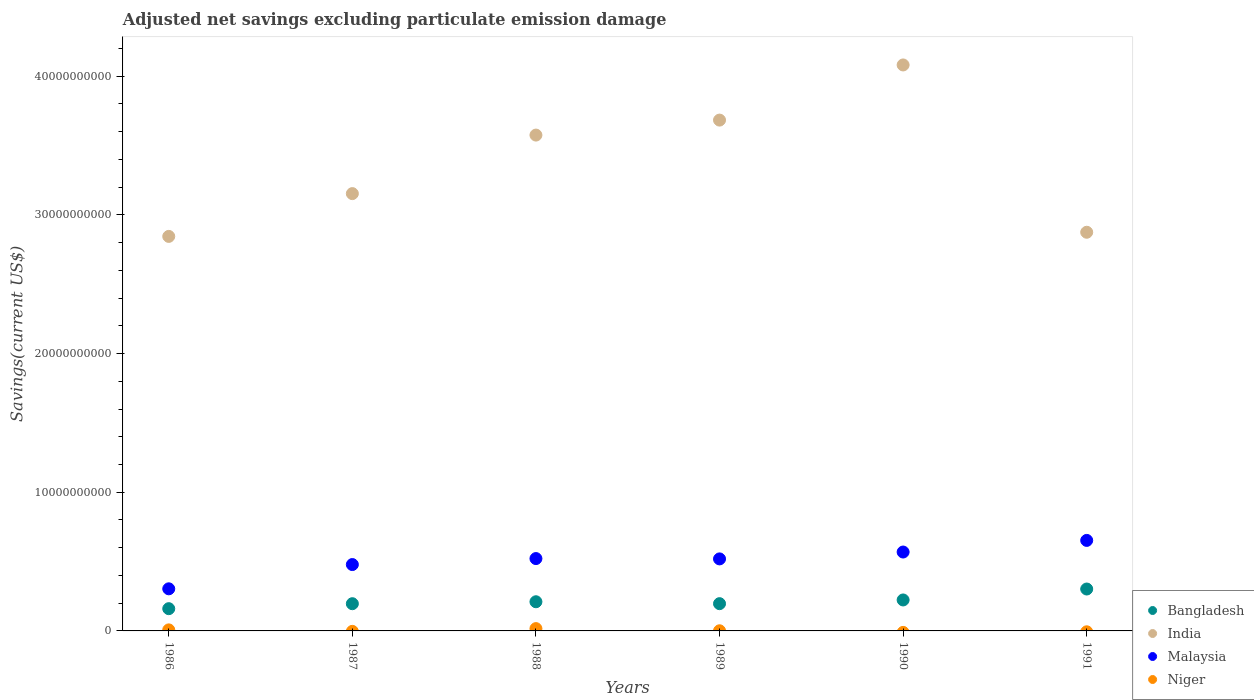What is the adjusted net savings in Malaysia in 1991?
Make the answer very short. 6.53e+09. Across all years, what is the maximum adjusted net savings in Niger?
Provide a succinct answer. 1.66e+08. Across all years, what is the minimum adjusted net savings in Bangladesh?
Ensure brevity in your answer.  1.60e+09. What is the total adjusted net savings in Niger in the graph?
Your response must be concise. 2.52e+08. What is the difference between the adjusted net savings in India in 1986 and that in 1991?
Offer a terse response. -2.99e+08. What is the difference between the adjusted net savings in Malaysia in 1986 and the adjusted net savings in Niger in 1987?
Your answer should be very brief. 3.04e+09. What is the average adjusted net savings in Bangladesh per year?
Offer a terse response. 2.15e+09. In the year 1989, what is the difference between the adjusted net savings in Malaysia and adjusted net savings in Niger?
Provide a short and direct response. 5.18e+09. In how many years, is the adjusted net savings in India greater than 30000000000 US$?
Make the answer very short. 4. What is the ratio of the adjusted net savings in Malaysia in 1986 to that in 1987?
Make the answer very short. 0.63. Is the adjusted net savings in Bangladesh in 1987 less than that in 1991?
Your answer should be compact. Yes. Is the difference between the adjusted net savings in Malaysia in 1986 and 1988 greater than the difference between the adjusted net savings in Niger in 1986 and 1988?
Make the answer very short. No. What is the difference between the highest and the second highest adjusted net savings in Malaysia?
Your response must be concise. 8.38e+08. What is the difference between the highest and the lowest adjusted net savings in Bangladesh?
Offer a terse response. 1.42e+09. Is the sum of the adjusted net savings in Niger in 1988 and 1989 greater than the maximum adjusted net savings in Malaysia across all years?
Give a very brief answer. No. Is it the case that in every year, the sum of the adjusted net savings in Bangladesh and adjusted net savings in Niger  is greater than the sum of adjusted net savings in India and adjusted net savings in Malaysia?
Offer a very short reply. Yes. Is it the case that in every year, the sum of the adjusted net savings in Bangladesh and adjusted net savings in India  is greater than the adjusted net savings in Malaysia?
Make the answer very short. Yes. Does the adjusted net savings in Malaysia monotonically increase over the years?
Offer a terse response. No. Is the adjusted net savings in Niger strictly greater than the adjusted net savings in Malaysia over the years?
Offer a terse response. No. How many dotlines are there?
Your response must be concise. 4. What is the difference between two consecutive major ticks on the Y-axis?
Keep it short and to the point. 1.00e+1. Where does the legend appear in the graph?
Ensure brevity in your answer.  Bottom right. How are the legend labels stacked?
Give a very brief answer. Vertical. What is the title of the graph?
Offer a terse response. Adjusted net savings excluding particulate emission damage. Does "Chile" appear as one of the legend labels in the graph?
Your answer should be compact. No. What is the label or title of the X-axis?
Your response must be concise. Years. What is the label or title of the Y-axis?
Give a very brief answer. Savings(current US$). What is the Savings(current US$) in Bangladesh in 1986?
Offer a very short reply. 1.60e+09. What is the Savings(current US$) of India in 1986?
Offer a terse response. 2.85e+1. What is the Savings(current US$) in Malaysia in 1986?
Provide a succinct answer. 3.04e+09. What is the Savings(current US$) of Niger in 1986?
Your answer should be very brief. 7.51e+07. What is the Savings(current US$) in Bangladesh in 1987?
Provide a short and direct response. 1.96e+09. What is the Savings(current US$) in India in 1987?
Offer a very short reply. 3.15e+1. What is the Savings(current US$) in Malaysia in 1987?
Keep it short and to the point. 4.79e+09. What is the Savings(current US$) of Bangladesh in 1988?
Your answer should be compact. 2.10e+09. What is the Savings(current US$) of India in 1988?
Offer a very short reply. 3.58e+1. What is the Savings(current US$) of Malaysia in 1988?
Your answer should be very brief. 5.22e+09. What is the Savings(current US$) in Niger in 1988?
Keep it short and to the point. 1.66e+08. What is the Savings(current US$) in Bangladesh in 1989?
Your answer should be very brief. 1.97e+09. What is the Savings(current US$) in India in 1989?
Give a very brief answer. 3.68e+1. What is the Savings(current US$) in Malaysia in 1989?
Make the answer very short. 5.19e+09. What is the Savings(current US$) of Niger in 1989?
Give a very brief answer. 1.02e+07. What is the Savings(current US$) in Bangladesh in 1990?
Give a very brief answer. 2.23e+09. What is the Savings(current US$) of India in 1990?
Provide a succinct answer. 4.08e+1. What is the Savings(current US$) in Malaysia in 1990?
Make the answer very short. 5.69e+09. What is the Savings(current US$) of Bangladesh in 1991?
Keep it short and to the point. 3.02e+09. What is the Savings(current US$) in India in 1991?
Make the answer very short. 2.88e+1. What is the Savings(current US$) in Malaysia in 1991?
Make the answer very short. 6.53e+09. Across all years, what is the maximum Savings(current US$) in Bangladesh?
Provide a short and direct response. 3.02e+09. Across all years, what is the maximum Savings(current US$) of India?
Offer a terse response. 4.08e+1. Across all years, what is the maximum Savings(current US$) of Malaysia?
Offer a very short reply. 6.53e+09. Across all years, what is the maximum Savings(current US$) in Niger?
Your answer should be compact. 1.66e+08. Across all years, what is the minimum Savings(current US$) of Bangladesh?
Give a very brief answer. 1.60e+09. Across all years, what is the minimum Savings(current US$) of India?
Provide a succinct answer. 2.85e+1. Across all years, what is the minimum Savings(current US$) of Malaysia?
Keep it short and to the point. 3.04e+09. Across all years, what is the minimum Savings(current US$) in Niger?
Your answer should be very brief. 0. What is the total Savings(current US$) of Bangladesh in the graph?
Ensure brevity in your answer.  1.29e+1. What is the total Savings(current US$) in India in the graph?
Your answer should be very brief. 2.02e+11. What is the total Savings(current US$) of Malaysia in the graph?
Make the answer very short. 3.05e+1. What is the total Savings(current US$) in Niger in the graph?
Offer a very short reply. 2.52e+08. What is the difference between the Savings(current US$) in Bangladesh in 1986 and that in 1987?
Provide a succinct answer. -3.58e+08. What is the difference between the Savings(current US$) in India in 1986 and that in 1987?
Give a very brief answer. -3.09e+09. What is the difference between the Savings(current US$) of Malaysia in 1986 and that in 1987?
Give a very brief answer. -1.75e+09. What is the difference between the Savings(current US$) in Bangladesh in 1986 and that in 1988?
Offer a terse response. -4.99e+08. What is the difference between the Savings(current US$) of India in 1986 and that in 1988?
Provide a succinct answer. -7.31e+09. What is the difference between the Savings(current US$) in Malaysia in 1986 and that in 1988?
Provide a succinct answer. -2.18e+09. What is the difference between the Savings(current US$) of Niger in 1986 and that in 1988?
Give a very brief answer. -9.12e+07. What is the difference between the Savings(current US$) in Bangladesh in 1986 and that in 1989?
Provide a short and direct response. -3.62e+08. What is the difference between the Savings(current US$) of India in 1986 and that in 1989?
Provide a short and direct response. -8.39e+09. What is the difference between the Savings(current US$) of Malaysia in 1986 and that in 1989?
Make the answer very short. -2.16e+09. What is the difference between the Savings(current US$) in Niger in 1986 and that in 1989?
Your answer should be compact. 6.48e+07. What is the difference between the Savings(current US$) of Bangladesh in 1986 and that in 1990?
Offer a very short reply. -6.29e+08. What is the difference between the Savings(current US$) in India in 1986 and that in 1990?
Your response must be concise. -1.24e+1. What is the difference between the Savings(current US$) in Malaysia in 1986 and that in 1990?
Your answer should be compact. -2.65e+09. What is the difference between the Savings(current US$) in Bangladesh in 1986 and that in 1991?
Offer a very short reply. -1.42e+09. What is the difference between the Savings(current US$) of India in 1986 and that in 1991?
Ensure brevity in your answer.  -2.99e+08. What is the difference between the Savings(current US$) of Malaysia in 1986 and that in 1991?
Ensure brevity in your answer.  -3.49e+09. What is the difference between the Savings(current US$) of Bangladesh in 1987 and that in 1988?
Make the answer very short. -1.40e+08. What is the difference between the Savings(current US$) in India in 1987 and that in 1988?
Offer a terse response. -4.22e+09. What is the difference between the Savings(current US$) in Malaysia in 1987 and that in 1988?
Ensure brevity in your answer.  -4.32e+08. What is the difference between the Savings(current US$) in Bangladesh in 1987 and that in 1989?
Give a very brief answer. -3.15e+06. What is the difference between the Savings(current US$) of India in 1987 and that in 1989?
Offer a very short reply. -5.30e+09. What is the difference between the Savings(current US$) in Malaysia in 1987 and that in 1989?
Offer a terse response. -4.08e+08. What is the difference between the Savings(current US$) of Bangladesh in 1987 and that in 1990?
Your answer should be very brief. -2.70e+08. What is the difference between the Savings(current US$) of India in 1987 and that in 1990?
Provide a short and direct response. -9.28e+09. What is the difference between the Savings(current US$) of Malaysia in 1987 and that in 1990?
Provide a short and direct response. -9.03e+08. What is the difference between the Savings(current US$) of Bangladesh in 1987 and that in 1991?
Your answer should be compact. -1.06e+09. What is the difference between the Savings(current US$) in India in 1987 and that in 1991?
Your answer should be very brief. 2.79e+09. What is the difference between the Savings(current US$) in Malaysia in 1987 and that in 1991?
Your answer should be very brief. -1.74e+09. What is the difference between the Savings(current US$) of Bangladesh in 1988 and that in 1989?
Provide a short and direct response. 1.37e+08. What is the difference between the Savings(current US$) of India in 1988 and that in 1989?
Your answer should be very brief. -1.08e+09. What is the difference between the Savings(current US$) in Malaysia in 1988 and that in 1989?
Your answer should be compact. 2.34e+07. What is the difference between the Savings(current US$) of Niger in 1988 and that in 1989?
Provide a short and direct response. 1.56e+08. What is the difference between the Savings(current US$) in Bangladesh in 1988 and that in 1990?
Provide a short and direct response. -1.30e+08. What is the difference between the Savings(current US$) of India in 1988 and that in 1990?
Your response must be concise. -5.06e+09. What is the difference between the Savings(current US$) of Malaysia in 1988 and that in 1990?
Offer a very short reply. -4.72e+08. What is the difference between the Savings(current US$) in Bangladesh in 1988 and that in 1991?
Provide a short and direct response. -9.19e+08. What is the difference between the Savings(current US$) in India in 1988 and that in 1991?
Keep it short and to the point. 7.01e+09. What is the difference between the Savings(current US$) of Malaysia in 1988 and that in 1991?
Make the answer very short. -1.31e+09. What is the difference between the Savings(current US$) of Bangladesh in 1989 and that in 1990?
Your response must be concise. -2.67e+08. What is the difference between the Savings(current US$) of India in 1989 and that in 1990?
Your response must be concise. -3.98e+09. What is the difference between the Savings(current US$) in Malaysia in 1989 and that in 1990?
Provide a succinct answer. -4.95e+08. What is the difference between the Savings(current US$) in Bangladesh in 1989 and that in 1991?
Offer a terse response. -1.06e+09. What is the difference between the Savings(current US$) of India in 1989 and that in 1991?
Ensure brevity in your answer.  8.09e+09. What is the difference between the Savings(current US$) of Malaysia in 1989 and that in 1991?
Offer a terse response. -1.33e+09. What is the difference between the Savings(current US$) of Bangladesh in 1990 and that in 1991?
Provide a succinct answer. -7.89e+08. What is the difference between the Savings(current US$) of India in 1990 and that in 1991?
Keep it short and to the point. 1.21e+1. What is the difference between the Savings(current US$) of Malaysia in 1990 and that in 1991?
Provide a succinct answer. -8.38e+08. What is the difference between the Savings(current US$) of Bangladesh in 1986 and the Savings(current US$) of India in 1987?
Make the answer very short. -2.99e+1. What is the difference between the Savings(current US$) in Bangladesh in 1986 and the Savings(current US$) in Malaysia in 1987?
Provide a short and direct response. -3.18e+09. What is the difference between the Savings(current US$) of India in 1986 and the Savings(current US$) of Malaysia in 1987?
Give a very brief answer. 2.37e+1. What is the difference between the Savings(current US$) in Bangladesh in 1986 and the Savings(current US$) in India in 1988?
Offer a very short reply. -3.42e+1. What is the difference between the Savings(current US$) of Bangladesh in 1986 and the Savings(current US$) of Malaysia in 1988?
Your answer should be compact. -3.61e+09. What is the difference between the Savings(current US$) in Bangladesh in 1986 and the Savings(current US$) in Niger in 1988?
Offer a very short reply. 1.44e+09. What is the difference between the Savings(current US$) of India in 1986 and the Savings(current US$) of Malaysia in 1988?
Ensure brevity in your answer.  2.32e+1. What is the difference between the Savings(current US$) of India in 1986 and the Savings(current US$) of Niger in 1988?
Offer a terse response. 2.83e+1. What is the difference between the Savings(current US$) of Malaysia in 1986 and the Savings(current US$) of Niger in 1988?
Ensure brevity in your answer.  2.87e+09. What is the difference between the Savings(current US$) of Bangladesh in 1986 and the Savings(current US$) of India in 1989?
Ensure brevity in your answer.  -3.52e+1. What is the difference between the Savings(current US$) of Bangladesh in 1986 and the Savings(current US$) of Malaysia in 1989?
Provide a succinct answer. -3.59e+09. What is the difference between the Savings(current US$) in Bangladesh in 1986 and the Savings(current US$) in Niger in 1989?
Your response must be concise. 1.59e+09. What is the difference between the Savings(current US$) in India in 1986 and the Savings(current US$) in Malaysia in 1989?
Offer a terse response. 2.33e+1. What is the difference between the Savings(current US$) in India in 1986 and the Savings(current US$) in Niger in 1989?
Your answer should be compact. 2.84e+1. What is the difference between the Savings(current US$) in Malaysia in 1986 and the Savings(current US$) in Niger in 1989?
Offer a very short reply. 3.03e+09. What is the difference between the Savings(current US$) of Bangladesh in 1986 and the Savings(current US$) of India in 1990?
Ensure brevity in your answer.  -3.92e+1. What is the difference between the Savings(current US$) of Bangladesh in 1986 and the Savings(current US$) of Malaysia in 1990?
Your answer should be compact. -4.09e+09. What is the difference between the Savings(current US$) in India in 1986 and the Savings(current US$) in Malaysia in 1990?
Your answer should be compact. 2.28e+1. What is the difference between the Savings(current US$) in Bangladesh in 1986 and the Savings(current US$) in India in 1991?
Keep it short and to the point. -2.71e+1. What is the difference between the Savings(current US$) in Bangladesh in 1986 and the Savings(current US$) in Malaysia in 1991?
Ensure brevity in your answer.  -4.92e+09. What is the difference between the Savings(current US$) of India in 1986 and the Savings(current US$) of Malaysia in 1991?
Offer a very short reply. 2.19e+1. What is the difference between the Savings(current US$) of Bangladesh in 1987 and the Savings(current US$) of India in 1988?
Your answer should be very brief. -3.38e+1. What is the difference between the Savings(current US$) in Bangladesh in 1987 and the Savings(current US$) in Malaysia in 1988?
Offer a terse response. -3.25e+09. What is the difference between the Savings(current US$) of Bangladesh in 1987 and the Savings(current US$) of Niger in 1988?
Your answer should be very brief. 1.80e+09. What is the difference between the Savings(current US$) in India in 1987 and the Savings(current US$) in Malaysia in 1988?
Make the answer very short. 2.63e+1. What is the difference between the Savings(current US$) in India in 1987 and the Savings(current US$) in Niger in 1988?
Offer a terse response. 3.14e+1. What is the difference between the Savings(current US$) in Malaysia in 1987 and the Savings(current US$) in Niger in 1988?
Provide a short and direct response. 4.62e+09. What is the difference between the Savings(current US$) in Bangladesh in 1987 and the Savings(current US$) in India in 1989?
Provide a short and direct response. -3.49e+1. What is the difference between the Savings(current US$) of Bangladesh in 1987 and the Savings(current US$) of Malaysia in 1989?
Keep it short and to the point. -3.23e+09. What is the difference between the Savings(current US$) of Bangladesh in 1987 and the Savings(current US$) of Niger in 1989?
Your answer should be compact. 1.95e+09. What is the difference between the Savings(current US$) of India in 1987 and the Savings(current US$) of Malaysia in 1989?
Keep it short and to the point. 2.63e+1. What is the difference between the Savings(current US$) of India in 1987 and the Savings(current US$) of Niger in 1989?
Your response must be concise. 3.15e+1. What is the difference between the Savings(current US$) of Malaysia in 1987 and the Savings(current US$) of Niger in 1989?
Make the answer very short. 4.78e+09. What is the difference between the Savings(current US$) of Bangladesh in 1987 and the Savings(current US$) of India in 1990?
Keep it short and to the point. -3.89e+1. What is the difference between the Savings(current US$) of Bangladesh in 1987 and the Savings(current US$) of Malaysia in 1990?
Offer a terse response. -3.73e+09. What is the difference between the Savings(current US$) of India in 1987 and the Savings(current US$) of Malaysia in 1990?
Your response must be concise. 2.58e+1. What is the difference between the Savings(current US$) in Bangladesh in 1987 and the Savings(current US$) in India in 1991?
Provide a succinct answer. -2.68e+1. What is the difference between the Savings(current US$) of Bangladesh in 1987 and the Savings(current US$) of Malaysia in 1991?
Offer a very short reply. -4.56e+09. What is the difference between the Savings(current US$) in India in 1987 and the Savings(current US$) in Malaysia in 1991?
Offer a terse response. 2.50e+1. What is the difference between the Savings(current US$) in Bangladesh in 1988 and the Savings(current US$) in India in 1989?
Your response must be concise. -3.47e+1. What is the difference between the Savings(current US$) of Bangladesh in 1988 and the Savings(current US$) of Malaysia in 1989?
Ensure brevity in your answer.  -3.09e+09. What is the difference between the Savings(current US$) in Bangladesh in 1988 and the Savings(current US$) in Niger in 1989?
Your response must be concise. 2.09e+09. What is the difference between the Savings(current US$) of India in 1988 and the Savings(current US$) of Malaysia in 1989?
Offer a terse response. 3.06e+1. What is the difference between the Savings(current US$) of India in 1988 and the Savings(current US$) of Niger in 1989?
Offer a terse response. 3.57e+1. What is the difference between the Savings(current US$) of Malaysia in 1988 and the Savings(current US$) of Niger in 1989?
Offer a terse response. 5.21e+09. What is the difference between the Savings(current US$) in Bangladesh in 1988 and the Savings(current US$) in India in 1990?
Give a very brief answer. -3.87e+1. What is the difference between the Savings(current US$) in Bangladesh in 1988 and the Savings(current US$) in Malaysia in 1990?
Provide a succinct answer. -3.59e+09. What is the difference between the Savings(current US$) of India in 1988 and the Savings(current US$) of Malaysia in 1990?
Offer a very short reply. 3.01e+1. What is the difference between the Savings(current US$) in Bangladesh in 1988 and the Savings(current US$) in India in 1991?
Keep it short and to the point. -2.66e+1. What is the difference between the Savings(current US$) of Bangladesh in 1988 and the Savings(current US$) of Malaysia in 1991?
Provide a succinct answer. -4.42e+09. What is the difference between the Savings(current US$) of India in 1988 and the Savings(current US$) of Malaysia in 1991?
Your response must be concise. 2.92e+1. What is the difference between the Savings(current US$) of Bangladesh in 1989 and the Savings(current US$) of India in 1990?
Your response must be concise. -3.89e+1. What is the difference between the Savings(current US$) in Bangladesh in 1989 and the Savings(current US$) in Malaysia in 1990?
Your answer should be very brief. -3.72e+09. What is the difference between the Savings(current US$) in India in 1989 and the Savings(current US$) in Malaysia in 1990?
Provide a succinct answer. 3.11e+1. What is the difference between the Savings(current US$) of Bangladesh in 1989 and the Savings(current US$) of India in 1991?
Keep it short and to the point. -2.68e+1. What is the difference between the Savings(current US$) of Bangladesh in 1989 and the Savings(current US$) of Malaysia in 1991?
Ensure brevity in your answer.  -4.56e+09. What is the difference between the Savings(current US$) in India in 1989 and the Savings(current US$) in Malaysia in 1991?
Ensure brevity in your answer.  3.03e+1. What is the difference between the Savings(current US$) of Bangladesh in 1990 and the Savings(current US$) of India in 1991?
Your answer should be very brief. -2.65e+1. What is the difference between the Savings(current US$) of Bangladesh in 1990 and the Savings(current US$) of Malaysia in 1991?
Give a very brief answer. -4.29e+09. What is the difference between the Savings(current US$) of India in 1990 and the Savings(current US$) of Malaysia in 1991?
Ensure brevity in your answer.  3.43e+1. What is the average Savings(current US$) in Bangladesh per year?
Ensure brevity in your answer.  2.15e+09. What is the average Savings(current US$) in India per year?
Provide a succinct answer. 3.37e+1. What is the average Savings(current US$) of Malaysia per year?
Ensure brevity in your answer.  5.08e+09. What is the average Savings(current US$) in Niger per year?
Keep it short and to the point. 4.19e+07. In the year 1986, what is the difference between the Savings(current US$) in Bangladesh and Savings(current US$) in India?
Give a very brief answer. -2.68e+1. In the year 1986, what is the difference between the Savings(current US$) in Bangladesh and Savings(current US$) in Malaysia?
Your answer should be very brief. -1.43e+09. In the year 1986, what is the difference between the Savings(current US$) in Bangladesh and Savings(current US$) in Niger?
Make the answer very short. 1.53e+09. In the year 1986, what is the difference between the Savings(current US$) of India and Savings(current US$) of Malaysia?
Offer a very short reply. 2.54e+1. In the year 1986, what is the difference between the Savings(current US$) of India and Savings(current US$) of Niger?
Your answer should be compact. 2.84e+1. In the year 1986, what is the difference between the Savings(current US$) in Malaysia and Savings(current US$) in Niger?
Make the answer very short. 2.96e+09. In the year 1987, what is the difference between the Savings(current US$) of Bangladesh and Savings(current US$) of India?
Provide a short and direct response. -2.96e+1. In the year 1987, what is the difference between the Savings(current US$) in Bangladesh and Savings(current US$) in Malaysia?
Offer a very short reply. -2.82e+09. In the year 1987, what is the difference between the Savings(current US$) of India and Savings(current US$) of Malaysia?
Provide a succinct answer. 2.68e+1. In the year 1988, what is the difference between the Savings(current US$) in Bangladesh and Savings(current US$) in India?
Provide a short and direct response. -3.37e+1. In the year 1988, what is the difference between the Savings(current US$) of Bangladesh and Savings(current US$) of Malaysia?
Ensure brevity in your answer.  -3.11e+09. In the year 1988, what is the difference between the Savings(current US$) in Bangladesh and Savings(current US$) in Niger?
Make the answer very short. 1.94e+09. In the year 1988, what is the difference between the Savings(current US$) in India and Savings(current US$) in Malaysia?
Your response must be concise. 3.05e+1. In the year 1988, what is the difference between the Savings(current US$) in India and Savings(current US$) in Niger?
Your answer should be compact. 3.56e+1. In the year 1988, what is the difference between the Savings(current US$) of Malaysia and Savings(current US$) of Niger?
Provide a short and direct response. 5.05e+09. In the year 1989, what is the difference between the Savings(current US$) in Bangladesh and Savings(current US$) in India?
Provide a short and direct response. -3.49e+1. In the year 1989, what is the difference between the Savings(current US$) in Bangladesh and Savings(current US$) in Malaysia?
Your answer should be compact. -3.23e+09. In the year 1989, what is the difference between the Savings(current US$) in Bangladesh and Savings(current US$) in Niger?
Your response must be concise. 1.96e+09. In the year 1989, what is the difference between the Savings(current US$) in India and Savings(current US$) in Malaysia?
Ensure brevity in your answer.  3.16e+1. In the year 1989, what is the difference between the Savings(current US$) of India and Savings(current US$) of Niger?
Your response must be concise. 3.68e+1. In the year 1989, what is the difference between the Savings(current US$) in Malaysia and Savings(current US$) in Niger?
Offer a terse response. 5.18e+09. In the year 1990, what is the difference between the Savings(current US$) in Bangladesh and Savings(current US$) in India?
Offer a very short reply. -3.86e+1. In the year 1990, what is the difference between the Savings(current US$) of Bangladesh and Savings(current US$) of Malaysia?
Give a very brief answer. -3.46e+09. In the year 1990, what is the difference between the Savings(current US$) in India and Savings(current US$) in Malaysia?
Offer a very short reply. 3.51e+1. In the year 1991, what is the difference between the Savings(current US$) of Bangladesh and Savings(current US$) of India?
Your answer should be compact. -2.57e+1. In the year 1991, what is the difference between the Savings(current US$) in Bangladesh and Savings(current US$) in Malaysia?
Provide a short and direct response. -3.51e+09. In the year 1991, what is the difference between the Savings(current US$) in India and Savings(current US$) in Malaysia?
Provide a succinct answer. 2.22e+1. What is the ratio of the Savings(current US$) in Bangladesh in 1986 to that in 1987?
Make the answer very short. 0.82. What is the ratio of the Savings(current US$) in India in 1986 to that in 1987?
Ensure brevity in your answer.  0.9. What is the ratio of the Savings(current US$) of Malaysia in 1986 to that in 1987?
Your response must be concise. 0.63. What is the ratio of the Savings(current US$) in Bangladesh in 1986 to that in 1988?
Your answer should be compact. 0.76. What is the ratio of the Savings(current US$) in India in 1986 to that in 1988?
Keep it short and to the point. 0.8. What is the ratio of the Savings(current US$) of Malaysia in 1986 to that in 1988?
Offer a terse response. 0.58. What is the ratio of the Savings(current US$) of Niger in 1986 to that in 1988?
Your response must be concise. 0.45. What is the ratio of the Savings(current US$) of Bangladesh in 1986 to that in 1989?
Offer a very short reply. 0.82. What is the ratio of the Savings(current US$) in India in 1986 to that in 1989?
Offer a very short reply. 0.77. What is the ratio of the Savings(current US$) of Malaysia in 1986 to that in 1989?
Give a very brief answer. 0.58. What is the ratio of the Savings(current US$) in Niger in 1986 to that in 1989?
Make the answer very short. 7.33. What is the ratio of the Savings(current US$) in Bangladesh in 1986 to that in 1990?
Keep it short and to the point. 0.72. What is the ratio of the Savings(current US$) in India in 1986 to that in 1990?
Give a very brief answer. 0.7. What is the ratio of the Savings(current US$) in Malaysia in 1986 to that in 1990?
Your answer should be very brief. 0.53. What is the ratio of the Savings(current US$) of Bangladesh in 1986 to that in 1991?
Make the answer very short. 0.53. What is the ratio of the Savings(current US$) in Malaysia in 1986 to that in 1991?
Your answer should be compact. 0.47. What is the ratio of the Savings(current US$) of Bangladesh in 1987 to that in 1988?
Offer a very short reply. 0.93. What is the ratio of the Savings(current US$) in India in 1987 to that in 1988?
Your answer should be very brief. 0.88. What is the ratio of the Savings(current US$) of Malaysia in 1987 to that in 1988?
Give a very brief answer. 0.92. What is the ratio of the Savings(current US$) in India in 1987 to that in 1989?
Your answer should be very brief. 0.86. What is the ratio of the Savings(current US$) in Malaysia in 1987 to that in 1989?
Offer a very short reply. 0.92. What is the ratio of the Savings(current US$) in Bangladesh in 1987 to that in 1990?
Offer a terse response. 0.88. What is the ratio of the Savings(current US$) of India in 1987 to that in 1990?
Provide a succinct answer. 0.77. What is the ratio of the Savings(current US$) in Malaysia in 1987 to that in 1990?
Provide a succinct answer. 0.84. What is the ratio of the Savings(current US$) in Bangladesh in 1987 to that in 1991?
Provide a short and direct response. 0.65. What is the ratio of the Savings(current US$) of India in 1987 to that in 1991?
Make the answer very short. 1.1. What is the ratio of the Savings(current US$) of Malaysia in 1987 to that in 1991?
Your answer should be compact. 0.73. What is the ratio of the Savings(current US$) in Bangladesh in 1988 to that in 1989?
Your answer should be compact. 1.07. What is the ratio of the Savings(current US$) of India in 1988 to that in 1989?
Give a very brief answer. 0.97. What is the ratio of the Savings(current US$) in Niger in 1988 to that in 1989?
Your answer should be compact. 16.25. What is the ratio of the Savings(current US$) of Bangladesh in 1988 to that in 1990?
Provide a succinct answer. 0.94. What is the ratio of the Savings(current US$) of India in 1988 to that in 1990?
Offer a terse response. 0.88. What is the ratio of the Savings(current US$) in Malaysia in 1988 to that in 1990?
Provide a short and direct response. 0.92. What is the ratio of the Savings(current US$) in Bangladesh in 1988 to that in 1991?
Your response must be concise. 0.7. What is the ratio of the Savings(current US$) in India in 1988 to that in 1991?
Offer a very short reply. 1.24. What is the ratio of the Savings(current US$) of Malaysia in 1988 to that in 1991?
Make the answer very short. 0.8. What is the ratio of the Savings(current US$) of Bangladesh in 1989 to that in 1990?
Your response must be concise. 0.88. What is the ratio of the Savings(current US$) in India in 1989 to that in 1990?
Your response must be concise. 0.9. What is the ratio of the Savings(current US$) of Malaysia in 1989 to that in 1990?
Offer a very short reply. 0.91. What is the ratio of the Savings(current US$) in Bangladesh in 1989 to that in 1991?
Give a very brief answer. 0.65. What is the ratio of the Savings(current US$) in India in 1989 to that in 1991?
Provide a succinct answer. 1.28. What is the ratio of the Savings(current US$) in Malaysia in 1989 to that in 1991?
Make the answer very short. 0.8. What is the ratio of the Savings(current US$) in Bangladesh in 1990 to that in 1991?
Provide a short and direct response. 0.74. What is the ratio of the Savings(current US$) of India in 1990 to that in 1991?
Offer a terse response. 1.42. What is the ratio of the Savings(current US$) in Malaysia in 1990 to that in 1991?
Give a very brief answer. 0.87. What is the difference between the highest and the second highest Savings(current US$) of Bangladesh?
Provide a short and direct response. 7.89e+08. What is the difference between the highest and the second highest Savings(current US$) of India?
Your answer should be very brief. 3.98e+09. What is the difference between the highest and the second highest Savings(current US$) in Malaysia?
Provide a succinct answer. 8.38e+08. What is the difference between the highest and the second highest Savings(current US$) in Niger?
Offer a terse response. 9.12e+07. What is the difference between the highest and the lowest Savings(current US$) of Bangladesh?
Give a very brief answer. 1.42e+09. What is the difference between the highest and the lowest Savings(current US$) in India?
Offer a terse response. 1.24e+1. What is the difference between the highest and the lowest Savings(current US$) in Malaysia?
Make the answer very short. 3.49e+09. What is the difference between the highest and the lowest Savings(current US$) of Niger?
Make the answer very short. 1.66e+08. 